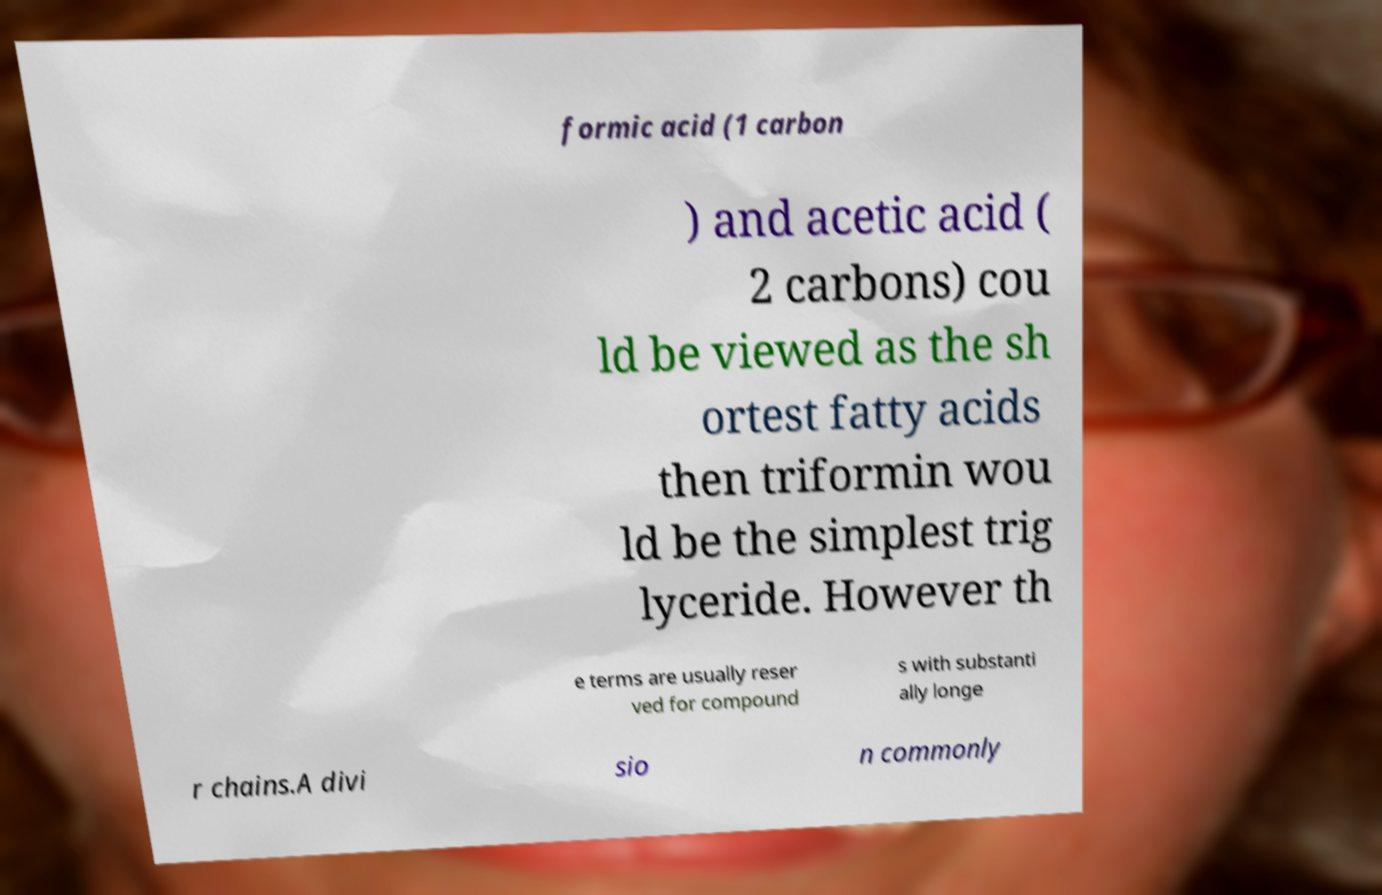There's text embedded in this image that I need extracted. Can you transcribe it verbatim? formic acid (1 carbon ) and acetic acid ( 2 carbons) cou ld be viewed as the sh ortest fatty acids then triformin wou ld be the simplest trig lyceride. However th e terms are usually reser ved for compound s with substanti ally longe r chains.A divi sio n commonly 